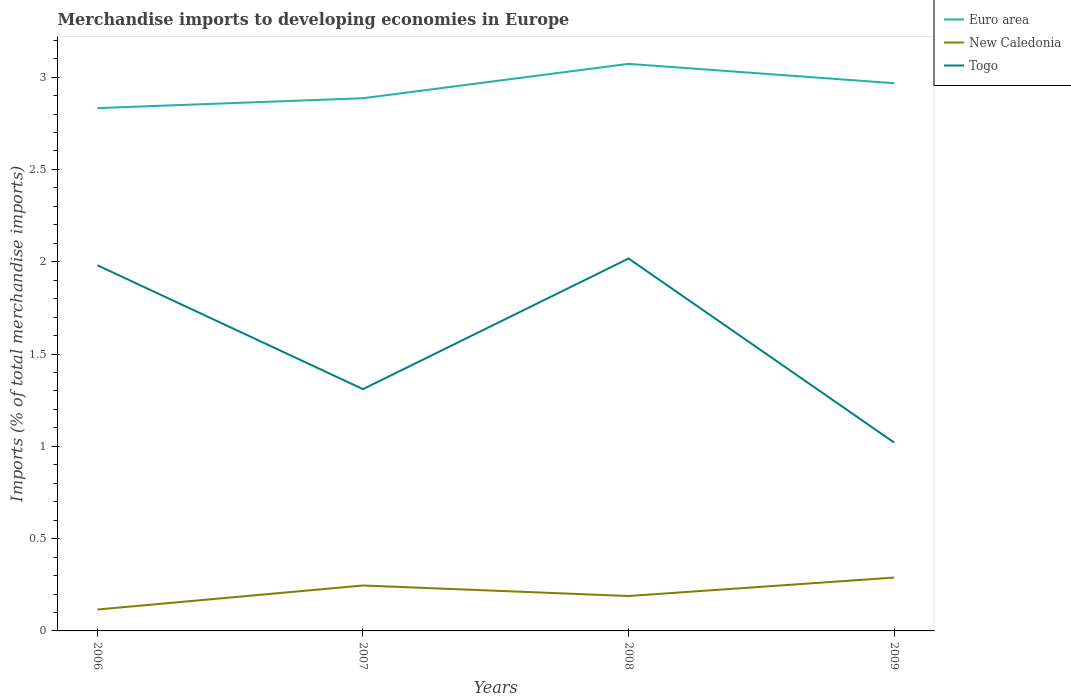Across all years, what is the maximum percentage total merchandise imports in Euro area?
Keep it short and to the point. 2.83. What is the total percentage total merchandise imports in Togo in the graph?
Your response must be concise. 1. What is the difference between the highest and the second highest percentage total merchandise imports in New Caledonia?
Provide a short and direct response. 0.17. Is the percentage total merchandise imports in New Caledonia strictly greater than the percentage total merchandise imports in Togo over the years?
Make the answer very short. Yes. How many lines are there?
Your response must be concise. 3. How many years are there in the graph?
Make the answer very short. 4. Does the graph contain any zero values?
Provide a succinct answer. No. What is the title of the graph?
Provide a succinct answer. Merchandise imports to developing economies in Europe. Does "Benin" appear as one of the legend labels in the graph?
Keep it short and to the point. No. What is the label or title of the Y-axis?
Offer a terse response. Imports (% of total merchandise imports). What is the Imports (% of total merchandise imports) in Euro area in 2006?
Provide a succinct answer. 2.83. What is the Imports (% of total merchandise imports) in New Caledonia in 2006?
Provide a short and direct response. 0.12. What is the Imports (% of total merchandise imports) of Togo in 2006?
Your answer should be compact. 1.98. What is the Imports (% of total merchandise imports) of Euro area in 2007?
Your response must be concise. 2.89. What is the Imports (% of total merchandise imports) of New Caledonia in 2007?
Offer a terse response. 0.25. What is the Imports (% of total merchandise imports) of Togo in 2007?
Your answer should be compact. 1.31. What is the Imports (% of total merchandise imports) in Euro area in 2008?
Provide a short and direct response. 3.07. What is the Imports (% of total merchandise imports) in New Caledonia in 2008?
Offer a terse response. 0.19. What is the Imports (% of total merchandise imports) of Togo in 2008?
Your answer should be compact. 2.02. What is the Imports (% of total merchandise imports) of Euro area in 2009?
Provide a short and direct response. 2.97. What is the Imports (% of total merchandise imports) in New Caledonia in 2009?
Ensure brevity in your answer.  0.29. What is the Imports (% of total merchandise imports) of Togo in 2009?
Offer a terse response. 1.02. Across all years, what is the maximum Imports (% of total merchandise imports) in Euro area?
Provide a succinct answer. 3.07. Across all years, what is the maximum Imports (% of total merchandise imports) of New Caledonia?
Your response must be concise. 0.29. Across all years, what is the maximum Imports (% of total merchandise imports) in Togo?
Give a very brief answer. 2.02. Across all years, what is the minimum Imports (% of total merchandise imports) in Euro area?
Offer a very short reply. 2.83. Across all years, what is the minimum Imports (% of total merchandise imports) in New Caledonia?
Offer a very short reply. 0.12. Across all years, what is the minimum Imports (% of total merchandise imports) of Togo?
Offer a terse response. 1.02. What is the total Imports (% of total merchandise imports) in Euro area in the graph?
Offer a terse response. 11.76. What is the total Imports (% of total merchandise imports) in New Caledonia in the graph?
Provide a succinct answer. 0.84. What is the total Imports (% of total merchandise imports) of Togo in the graph?
Your response must be concise. 6.33. What is the difference between the Imports (% of total merchandise imports) in Euro area in 2006 and that in 2007?
Your answer should be very brief. -0.05. What is the difference between the Imports (% of total merchandise imports) in New Caledonia in 2006 and that in 2007?
Offer a terse response. -0.13. What is the difference between the Imports (% of total merchandise imports) of Togo in 2006 and that in 2007?
Make the answer very short. 0.67. What is the difference between the Imports (% of total merchandise imports) in Euro area in 2006 and that in 2008?
Keep it short and to the point. -0.24. What is the difference between the Imports (% of total merchandise imports) in New Caledonia in 2006 and that in 2008?
Make the answer very short. -0.07. What is the difference between the Imports (% of total merchandise imports) in Togo in 2006 and that in 2008?
Your response must be concise. -0.04. What is the difference between the Imports (% of total merchandise imports) in Euro area in 2006 and that in 2009?
Your answer should be compact. -0.13. What is the difference between the Imports (% of total merchandise imports) in New Caledonia in 2006 and that in 2009?
Make the answer very short. -0.17. What is the difference between the Imports (% of total merchandise imports) of Togo in 2006 and that in 2009?
Ensure brevity in your answer.  0.96. What is the difference between the Imports (% of total merchandise imports) of Euro area in 2007 and that in 2008?
Provide a succinct answer. -0.19. What is the difference between the Imports (% of total merchandise imports) of New Caledonia in 2007 and that in 2008?
Your response must be concise. 0.06. What is the difference between the Imports (% of total merchandise imports) in Togo in 2007 and that in 2008?
Provide a succinct answer. -0.71. What is the difference between the Imports (% of total merchandise imports) in Euro area in 2007 and that in 2009?
Your answer should be compact. -0.08. What is the difference between the Imports (% of total merchandise imports) of New Caledonia in 2007 and that in 2009?
Keep it short and to the point. -0.04. What is the difference between the Imports (% of total merchandise imports) of Togo in 2007 and that in 2009?
Provide a short and direct response. 0.29. What is the difference between the Imports (% of total merchandise imports) of Euro area in 2008 and that in 2009?
Give a very brief answer. 0.1. What is the difference between the Imports (% of total merchandise imports) in New Caledonia in 2008 and that in 2009?
Your answer should be compact. -0.1. What is the difference between the Imports (% of total merchandise imports) of Togo in 2008 and that in 2009?
Offer a terse response. 1. What is the difference between the Imports (% of total merchandise imports) of Euro area in 2006 and the Imports (% of total merchandise imports) of New Caledonia in 2007?
Provide a succinct answer. 2.59. What is the difference between the Imports (% of total merchandise imports) in Euro area in 2006 and the Imports (% of total merchandise imports) in Togo in 2007?
Give a very brief answer. 1.52. What is the difference between the Imports (% of total merchandise imports) in New Caledonia in 2006 and the Imports (% of total merchandise imports) in Togo in 2007?
Give a very brief answer. -1.19. What is the difference between the Imports (% of total merchandise imports) in Euro area in 2006 and the Imports (% of total merchandise imports) in New Caledonia in 2008?
Make the answer very short. 2.64. What is the difference between the Imports (% of total merchandise imports) in Euro area in 2006 and the Imports (% of total merchandise imports) in Togo in 2008?
Keep it short and to the point. 0.81. What is the difference between the Imports (% of total merchandise imports) in New Caledonia in 2006 and the Imports (% of total merchandise imports) in Togo in 2008?
Ensure brevity in your answer.  -1.9. What is the difference between the Imports (% of total merchandise imports) of Euro area in 2006 and the Imports (% of total merchandise imports) of New Caledonia in 2009?
Your answer should be very brief. 2.54. What is the difference between the Imports (% of total merchandise imports) of Euro area in 2006 and the Imports (% of total merchandise imports) of Togo in 2009?
Keep it short and to the point. 1.81. What is the difference between the Imports (% of total merchandise imports) of New Caledonia in 2006 and the Imports (% of total merchandise imports) of Togo in 2009?
Provide a short and direct response. -0.9. What is the difference between the Imports (% of total merchandise imports) of Euro area in 2007 and the Imports (% of total merchandise imports) of New Caledonia in 2008?
Your answer should be very brief. 2.7. What is the difference between the Imports (% of total merchandise imports) of Euro area in 2007 and the Imports (% of total merchandise imports) of Togo in 2008?
Provide a succinct answer. 0.87. What is the difference between the Imports (% of total merchandise imports) in New Caledonia in 2007 and the Imports (% of total merchandise imports) in Togo in 2008?
Keep it short and to the point. -1.77. What is the difference between the Imports (% of total merchandise imports) of Euro area in 2007 and the Imports (% of total merchandise imports) of New Caledonia in 2009?
Give a very brief answer. 2.6. What is the difference between the Imports (% of total merchandise imports) of Euro area in 2007 and the Imports (% of total merchandise imports) of Togo in 2009?
Provide a short and direct response. 1.87. What is the difference between the Imports (% of total merchandise imports) in New Caledonia in 2007 and the Imports (% of total merchandise imports) in Togo in 2009?
Make the answer very short. -0.77. What is the difference between the Imports (% of total merchandise imports) in Euro area in 2008 and the Imports (% of total merchandise imports) in New Caledonia in 2009?
Make the answer very short. 2.78. What is the difference between the Imports (% of total merchandise imports) of Euro area in 2008 and the Imports (% of total merchandise imports) of Togo in 2009?
Provide a succinct answer. 2.05. What is the difference between the Imports (% of total merchandise imports) of New Caledonia in 2008 and the Imports (% of total merchandise imports) of Togo in 2009?
Offer a terse response. -0.83. What is the average Imports (% of total merchandise imports) in Euro area per year?
Make the answer very short. 2.94. What is the average Imports (% of total merchandise imports) in New Caledonia per year?
Provide a short and direct response. 0.21. What is the average Imports (% of total merchandise imports) of Togo per year?
Keep it short and to the point. 1.58. In the year 2006, what is the difference between the Imports (% of total merchandise imports) of Euro area and Imports (% of total merchandise imports) of New Caledonia?
Give a very brief answer. 2.72. In the year 2006, what is the difference between the Imports (% of total merchandise imports) in Euro area and Imports (% of total merchandise imports) in Togo?
Give a very brief answer. 0.85. In the year 2006, what is the difference between the Imports (% of total merchandise imports) in New Caledonia and Imports (% of total merchandise imports) in Togo?
Your response must be concise. -1.86. In the year 2007, what is the difference between the Imports (% of total merchandise imports) of Euro area and Imports (% of total merchandise imports) of New Caledonia?
Offer a very short reply. 2.64. In the year 2007, what is the difference between the Imports (% of total merchandise imports) in Euro area and Imports (% of total merchandise imports) in Togo?
Keep it short and to the point. 1.58. In the year 2007, what is the difference between the Imports (% of total merchandise imports) in New Caledonia and Imports (% of total merchandise imports) in Togo?
Provide a short and direct response. -1.06. In the year 2008, what is the difference between the Imports (% of total merchandise imports) in Euro area and Imports (% of total merchandise imports) in New Caledonia?
Ensure brevity in your answer.  2.88. In the year 2008, what is the difference between the Imports (% of total merchandise imports) in Euro area and Imports (% of total merchandise imports) in Togo?
Make the answer very short. 1.05. In the year 2008, what is the difference between the Imports (% of total merchandise imports) in New Caledonia and Imports (% of total merchandise imports) in Togo?
Ensure brevity in your answer.  -1.83. In the year 2009, what is the difference between the Imports (% of total merchandise imports) of Euro area and Imports (% of total merchandise imports) of New Caledonia?
Give a very brief answer. 2.68. In the year 2009, what is the difference between the Imports (% of total merchandise imports) in Euro area and Imports (% of total merchandise imports) in Togo?
Your response must be concise. 1.95. In the year 2009, what is the difference between the Imports (% of total merchandise imports) of New Caledonia and Imports (% of total merchandise imports) of Togo?
Offer a very short reply. -0.73. What is the ratio of the Imports (% of total merchandise imports) in Euro area in 2006 to that in 2007?
Make the answer very short. 0.98. What is the ratio of the Imports (% of total merchandise imports) in New Caledonia in 2006 to that in 2007?
Make the answer very short. 0.47. What is the ratio of the Imports (% of total merchandise imports) of Togo in 2006 to that in 2007?
Offer a terse response. 1.51. What is the ratio of the Imports (% of total merchandise imports) in Euro area in 2006 to that in 2008?
Ensure brevity in your answer.  0.92. What is the ratio of the Imports (% of total merchandise imports) in New Caledonia in 2006 to that in 2008?
Ensure brevity in your answer.  0.61. What is the ratio of the Imports (% of total merchandise imports) in Togo in 2006 to that in 2008?
Give a very brief answer. 0.98. What is the ratio of the Imports (% of total merchandise imports) in Euro area in 2006 to that in 2009?
Your response must be concise. 0.95. What is the ratio of the Imports (% of total merchandise imports) of New Caledonia in 2006 to that in 2009?
Provide a short and direct response. 0.4. What is the ratio of the Imports (% of total merchandise imports) in Togo in 2006 to that in 2009?
Keep it short and to the point. 1.94. What is the ratio of the Imports (% of total merchandise imports) in Euro area in 2007 to that in 2008?
Your response must be concise. 0.94. What is the ratio of the Imports (% of total merchandise imports) of New Caledonia in 2007 to that in 2008?
Your answer should be very brief. 1.3. What is the ratio of the Imports (% of total merchandise imports) of Togo in 2007 to that in 2008?
Offer a very short reply. 0.65. What is the ratio of the Imports (% of total merchandise imports) in Euro area in 2007 to that in 2009?
Keep it short and to the point. 0.97. What is the ratio of the Imports (% of total merchandise imports) in New Caledonia in 2007 to that in 2009?
Make the answer very short. 0.85. What is the ratio of the Imports (% of total merchandise imports) in Togo in 2007 to that in 2009?
Offer a terse response. 1.28. What is the ratio of the Imports (% of total merchandise imports) of Euro area in 2008 to that in 2009?
Offer a very short reply. 1.04. What is the ratio of the Imports (% of total merchandise imports) of New Caledonia in 2008 to that in 2009?
Provide a succinct answer. 0.65. What is the ratio of the Imports (% of total merchandise imports) in Togo in 2008 to that in 2009?
Provide a succinct answer. 1.98. What is the difference between the highest and the second highest Imports (% of total merchandise imports) of Euro area?
Offer a very short reply. 0.1. What is the difference between the highest and the second highest Imports (% of total merchandise imports) in New Caledonia?
Provide a short and direct response. 0.04. What is the difference between the highest and the second highest Imports (% of total merchandise imports) of Togo?
Keep it short and to the point. 0.04. What is the difference between the highest and the lowest Imports (% of total merchandise imports) in Euro area?
Ensure brevity in your answer.  0.24. What is the difference between the highest and the lowest Imports (% of total merchandise imports) of New Caledonia?
Offer a very short reply. 0.17. What is the difference between the highest and the lowest Imports (% of total merchandise imports) of Togo?
Your response must be concise. 1. 